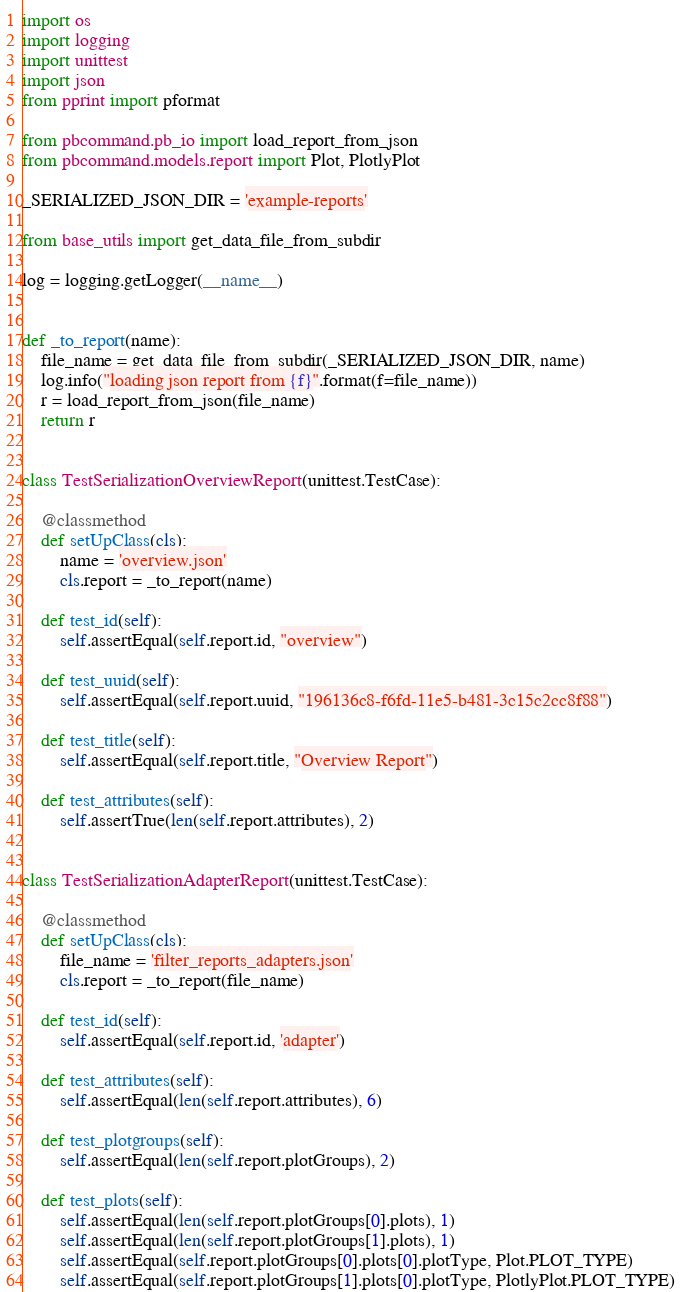<code> <loc_0><loc_0><loc_500><loc_500><_Python_>import os
import logging
import unittest
import json
from pprint import pformat

from pbcommand.pb_io import load_report_from_json
from pbcommand.models.report import Plot, PlotlyPlot

_SERIALIZED_JSON_DIR = 'example-reports'

from base_utils import get_data_file_from_subdir

log = logging.getLogger(__name__)


def _to_report(name):
    file_name = get_data_file_from_subdir(_SERIALIZED_JSON_DIR, name)
    log.info("loading json report from {f}".format(f=file_name))
    r = load_report_from_json(file_name)
    return r


class TestSerializationOverviewReport(unittest.TestCase):

    @classmethod
    def setUpClass(cls):
        name = 'overview.json'
        cls.report = _to_report(name)

    def test_id(self):
        self.assertEqual(self.report.id, "overview")

    def test_uuid(self):
        self.assertEqual(self.report.uuid, "196136c8-f6fd-11e5-b481-3c15c2cc8f88")

    def test_title(self):
        self.assertEqual(self.report.title, "Overview Report")

    def test_attributes(self):
        self.assertTrue(len(self.report.attributes), 2)


class TestSerializationAdapterReport(unittest.TestCase):

    @classmethod
    def setUpClass(cls):
        file_name = 'filter_reports_adapters.json'
        cls.report = _to_report(file_name)

    def test_id(self):
        self.assertEqual(self.report.id, 'adapter')

    def test_attributes(self):
        self.assertEqual(len(self.report.attributes), 6)

    def test_plotgroups(self):
        self.assertEqual(len(self.report.plotGroups), 2)

    def test_plots(self):
        self.assertEqual(len(self.report.plotGroups[0].plots), 1)
        self.assertEqual(len(self.report.plotGroups[1].plots), 1)
        self.assertEqual(self.report.plotGroups[0].plots[0].plotType, Plot.PLOT_TYPE)
        self.assertEqual(self.report.plotGroups[1].plots[0].plotType, PlotlyPlot.PLOT_TYPE)
</code> 